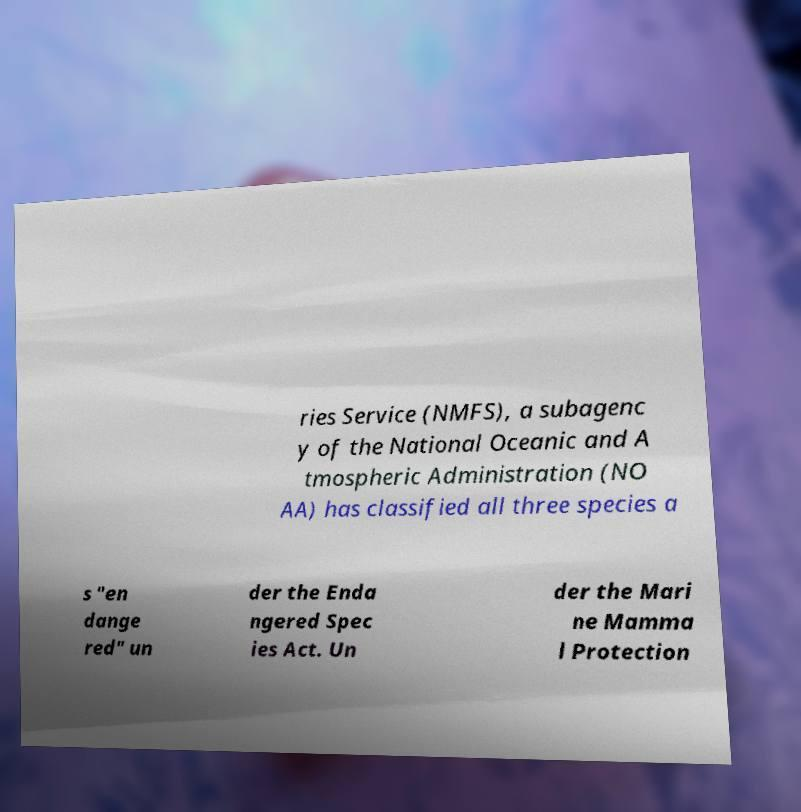Can you read and provide the text displayed in the image?This photo seems to have some interesting text. Can you extract and type it out for me? ries Service (NMFS), a subagenc y of the National Oceanic and A tmospheric Administration (NO AA) has classified all three species a s "en dange red" un der the Enda ngered Spec ies Act. Un der the Mari ne Mamma l Protection 